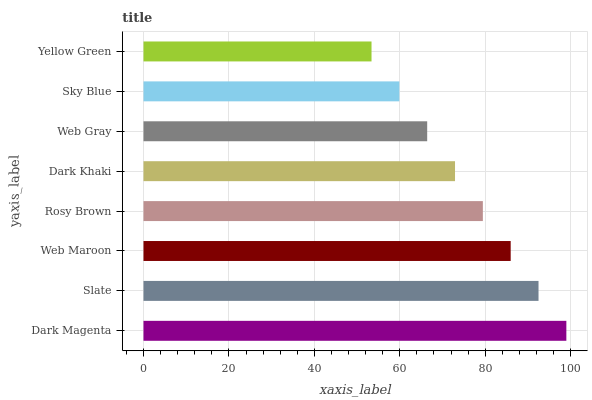Is Yellow Green the minimum?
Answer yes or no. Yes. Is Dark Magenta the maximum?
Answer yes or no. Yes. Is Slate the minimum?
Answer yes or no. No. Is Slate the maximum?
Answer yes or no. No. Is Dark Magenta greater than Slate?
Answer yes or no. Yes. Is Slate less than Dark Magenta?
Answer yes or no. Yes. Is Slate greater than Dark Magenta?
Answer yes or no. No. Is Dark Magenta less than Slate?
Answer yes or no. No. Is Rosy Brown the high median?
Answer yes or no. Yes. Is Dark Khaki the low median?
Answer yes or no. Yes. Is Web Maroon the high median?
Answer yes or no. No. Is Dark Magenta the low median?
Answer yes or no. No. 